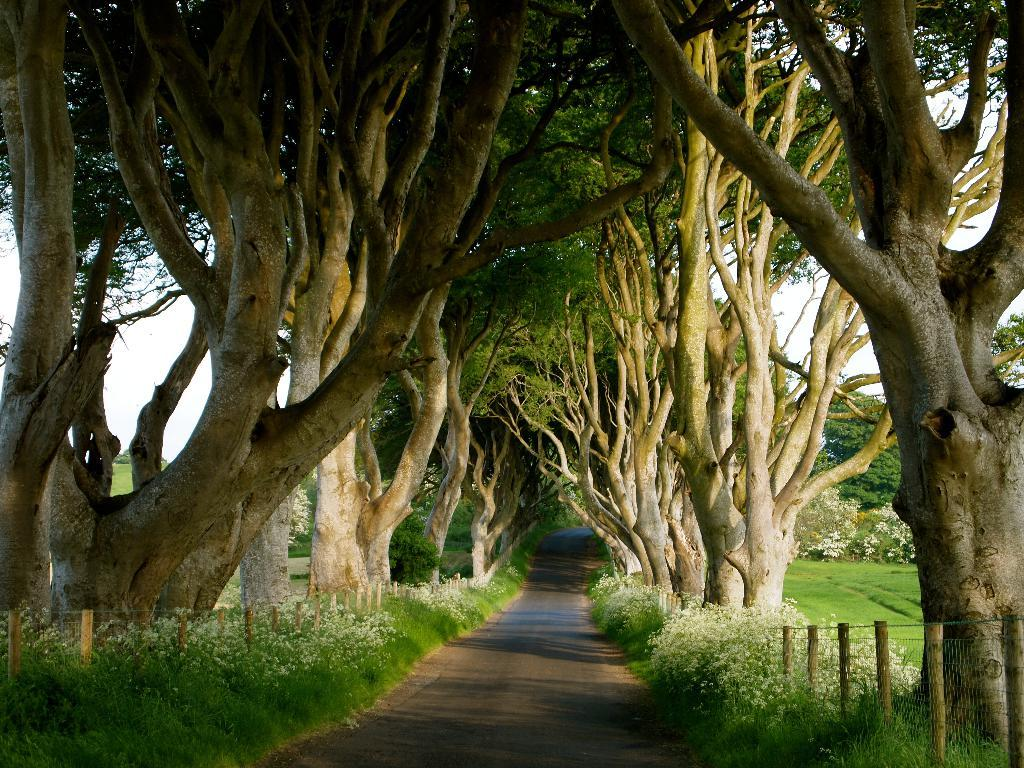What is the main feature of the image? There is a road in the image. What can be seen on both sides of the road? There are fences and trees on both sides of the road. What type of vegetation is present on both sides of the road? Grass is visible on both sides of the road. What is visible in the background of the image? The sky is visible behind the trees. How many books are stacked on the rock in the image? There is no rock or books present in the image. 